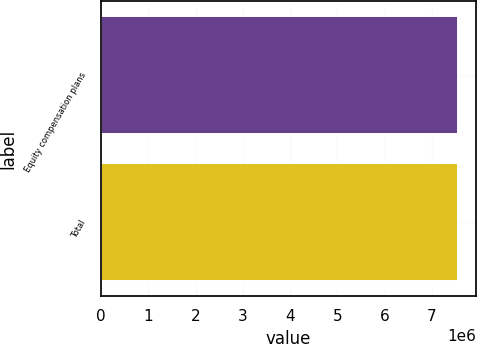<chart> <loc_0><loc_0><loc_500><loc_500><bar_chart><fcel>Equity compensation plans<fcel>Total<nl><fcel>7.55271e+06<fcel>7.55271e+06<nl></chart> 